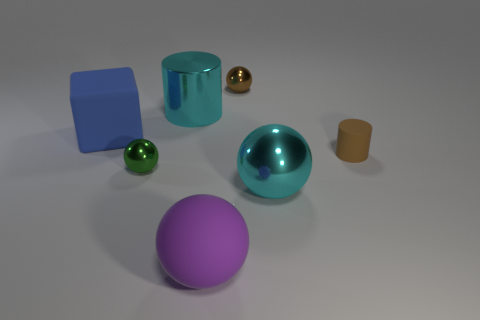Are there any patterns or symmetry in the arrangement of objects in this image? The objects in this image are arranged without strict symmetry or an immediately apparent pattern. They are placed at varying distances from each other, creating an asymmetrical composition that draws the eye around the image. The color and size variations amongst the objects provide a visual diversity that adds to the lack of a discernible pattern, resulting in a somewhat random, albeit aesthetically pleasing configuration. 